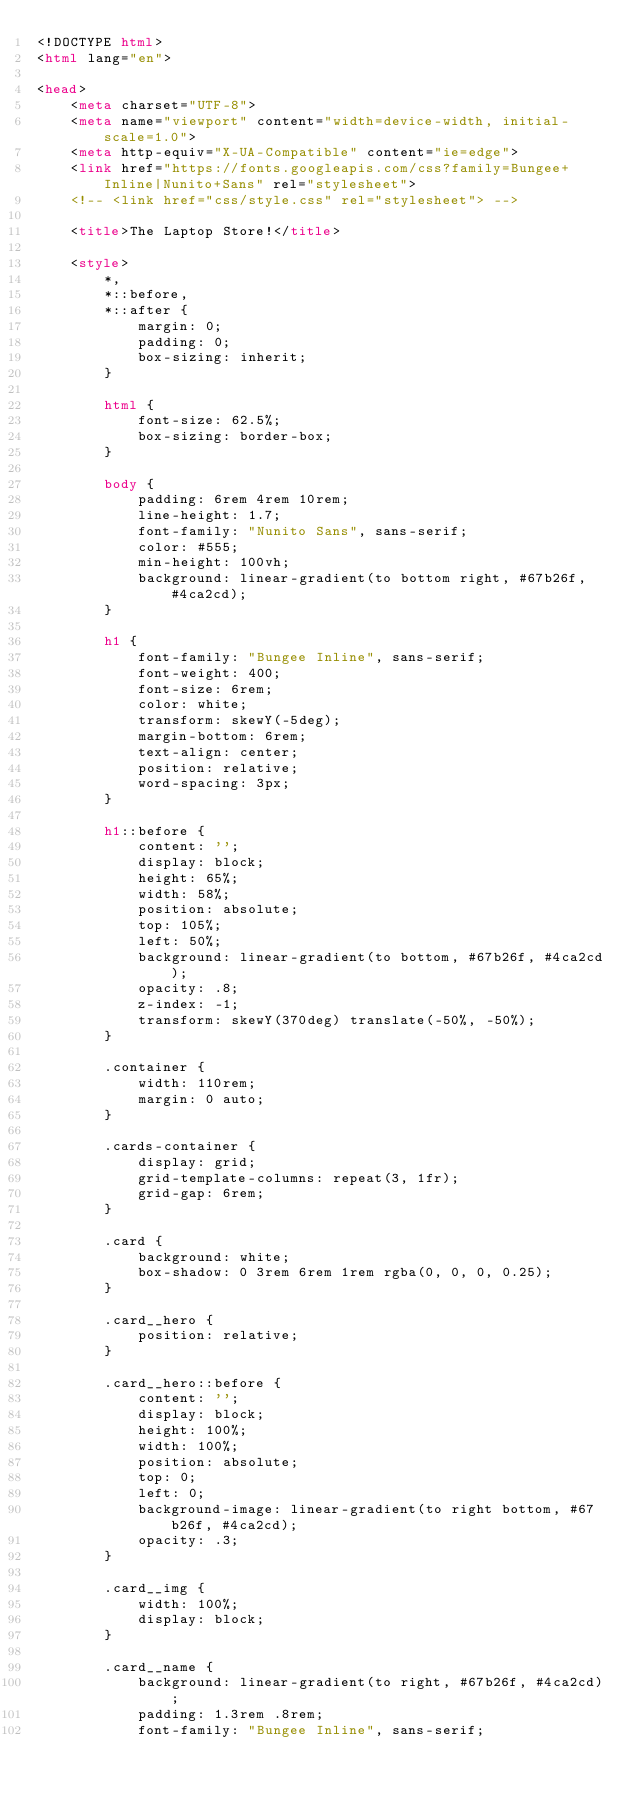Convert code to text. <code><loc_0><loc_0><loc_500><loc_500><_HTML_><!DOCTYPE html>
<html lang="en">

<head>
    <meta charset="UTF-8">
    <meta name="viewport" content="width=device-width, initial-scale=1.0">
    <meta http-equiv="X-UA-Compatible" content="ie=edge">
    <link href="https://fonts.googleapis.com/css?family=Bungee+Inline|Nunito+Sans" rel="stylesheet">
    <!-- <link href="css/style.css" rel="stylesheet"> -->

    <title>The Laptop Store!</title>

    <style>
        *,
        *::before,
        *::after {
            margin: 0;
            padding: 0;
            box-sizing: inherit;
        }

        html {
            font-size: 62.5%;
            box-sizing: border-box;
        }

        body {
            padding: 6rem 4rem 10rem;
            line-height: 1.7;
            font-family: "Nunito Sans", sans-serif;
            color: #555;
            min-height: 100vh;
            background: linear-gradient(to bottom right, #67b26f, #4ca2cd);
        }

        h1 {
            font-family: "Bungee Inline", sans-serif;
            font-weight: 400;
            font-size: 6rem;
            color: white;
            transform: skewY(-5deg);
            margin-bottom: 6rem;
            text-align: center;
            position: relative;
            word-spacing: 3px;
        }

        h1::before {
            content: '';
            display: block;
            height: 65%;
            width: 58%;
            position: absolute;
            top: 105%;
            left: 50%;
            background: linear-gradient(to bottom, #67b26f, #4ca2cd);
            opacity: .8;
            z-index: -1;
            transform: skewY(370deg) translate(-50%, -50%);
        }

        .container {
            width: 110rem;
            margin: 0 auto;
        }

        .cards-container {
            display: grid;
            grid-template-columns: repeat(3, 1fr);
            grid-gap: 6rem;
        }

        .card {
            background: white;
            box-shadow: 0 3rem 6rem 1rem rgba(0, 0, 0, 0.25);
        }

        .card__hero {
            position: relative;
        }

        .card__hero::before {
            content: '';
            display: block;
            height: 100%;
            width: 100%;
            position: absolute;
            top: 0;
            left: 0;
            background-image: linear-gradient(to right bottom, #67b26f, #4ca2cd);
            opacity: .3;
        }

        .card__img {
            width: 100%;
            display: block;
        }

        .card__name {
            background: linear-gradient(to right, #67b26f, #4ca2cd);
            padding: 1.3rem .8rem;
            font-family: "Bungee Inline", sans-serif;</code> 